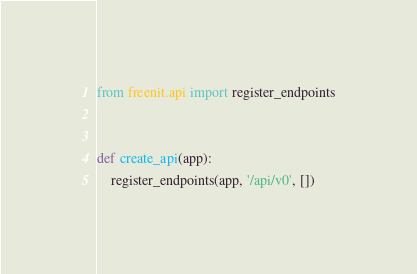Convert code to text. <code><loc_0><loc_0><loc_500><loc_500><_Python_>from freenit.api import register_endpoints


def create_api(app):
    register_endpoints(app, '/api/v0', [])
</code> 